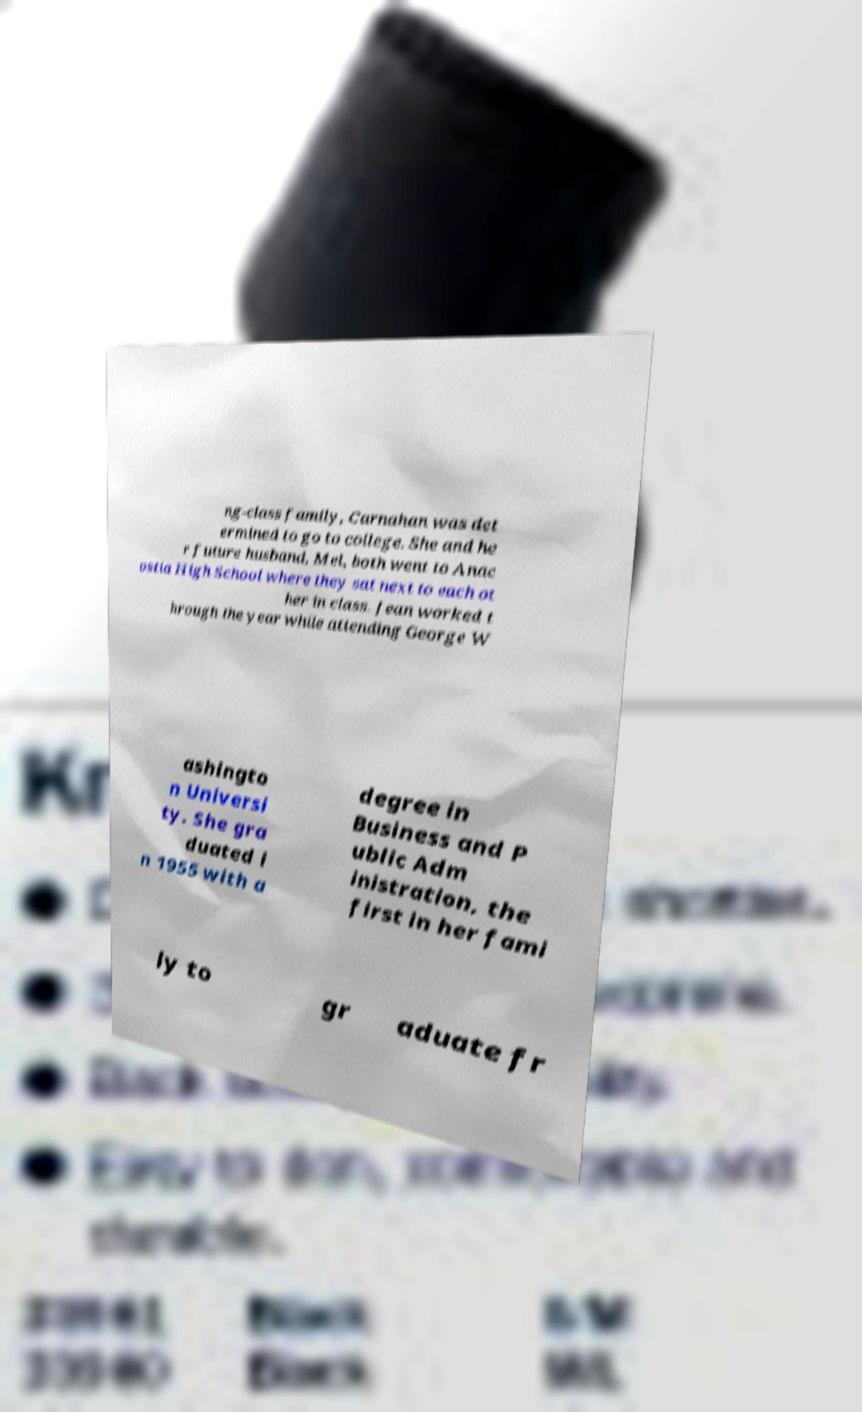For documentation purposes, I need the text within this image transcribed. Could you provide that? ng-class family, Carnahan was det ermined to go to college. She and he r future husband, Mel, both went to Anac ostia High School where they sat next to each ot her in class. Jean worked t hrough the year while attending George W ashingto n Universi ty. She gra duated i n 1955 with a degree in Business and P ublic Adm inistration, the first in her fami ly to gr aduate fr 